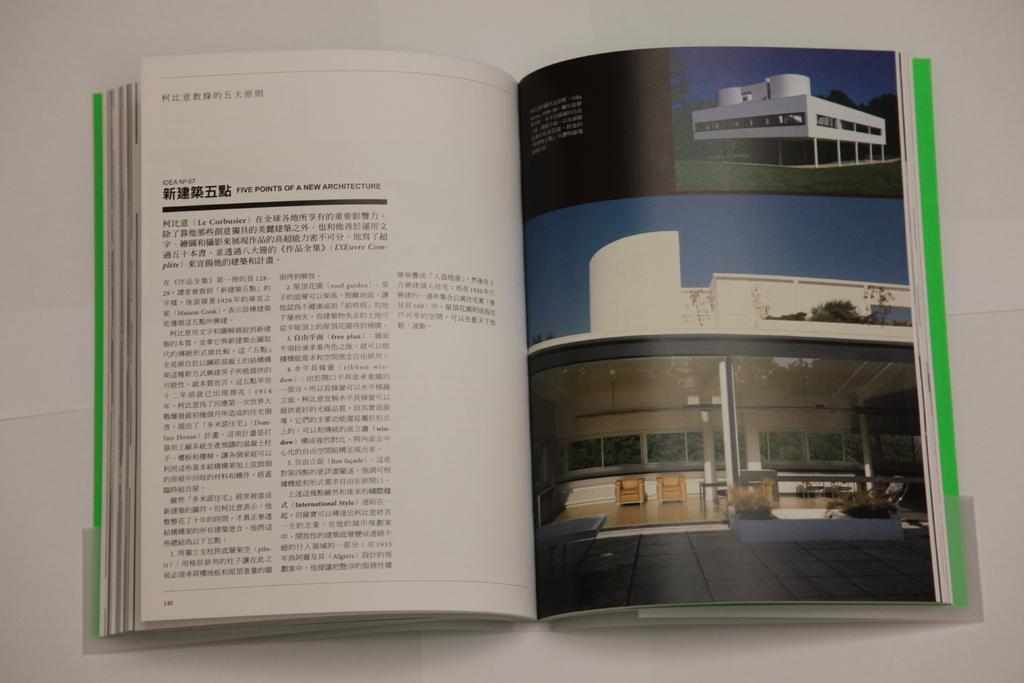What is the name of the chapter?
Give a very brief answer. Unanswerable. 